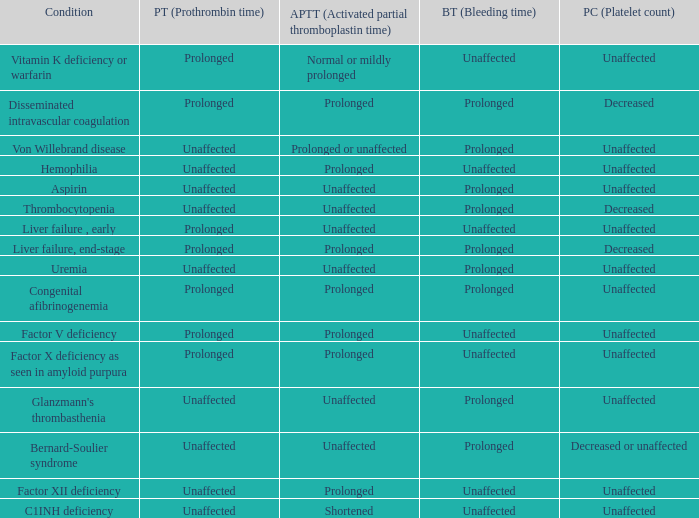Which partial thromboplastin time has a condition of liver failure , early? Unaffected. 